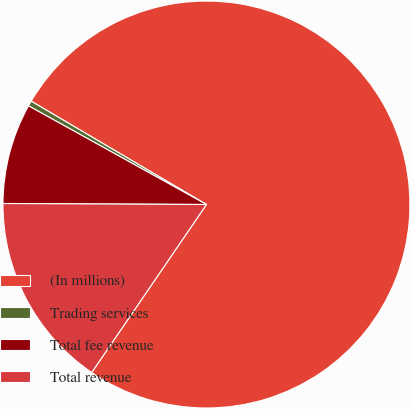Convert chart to OTSL. <chart><loc_0><loc_0><loc_500><loc_500><pie_chart><fcel>(In millions)<fcel>Trading services<fcel>Total fee revenue<fcel>Total revenue<nl><fcel>76.06%<fcel>0.42%<fcel>7.98%<fcel>15.54%<nl></chart> 